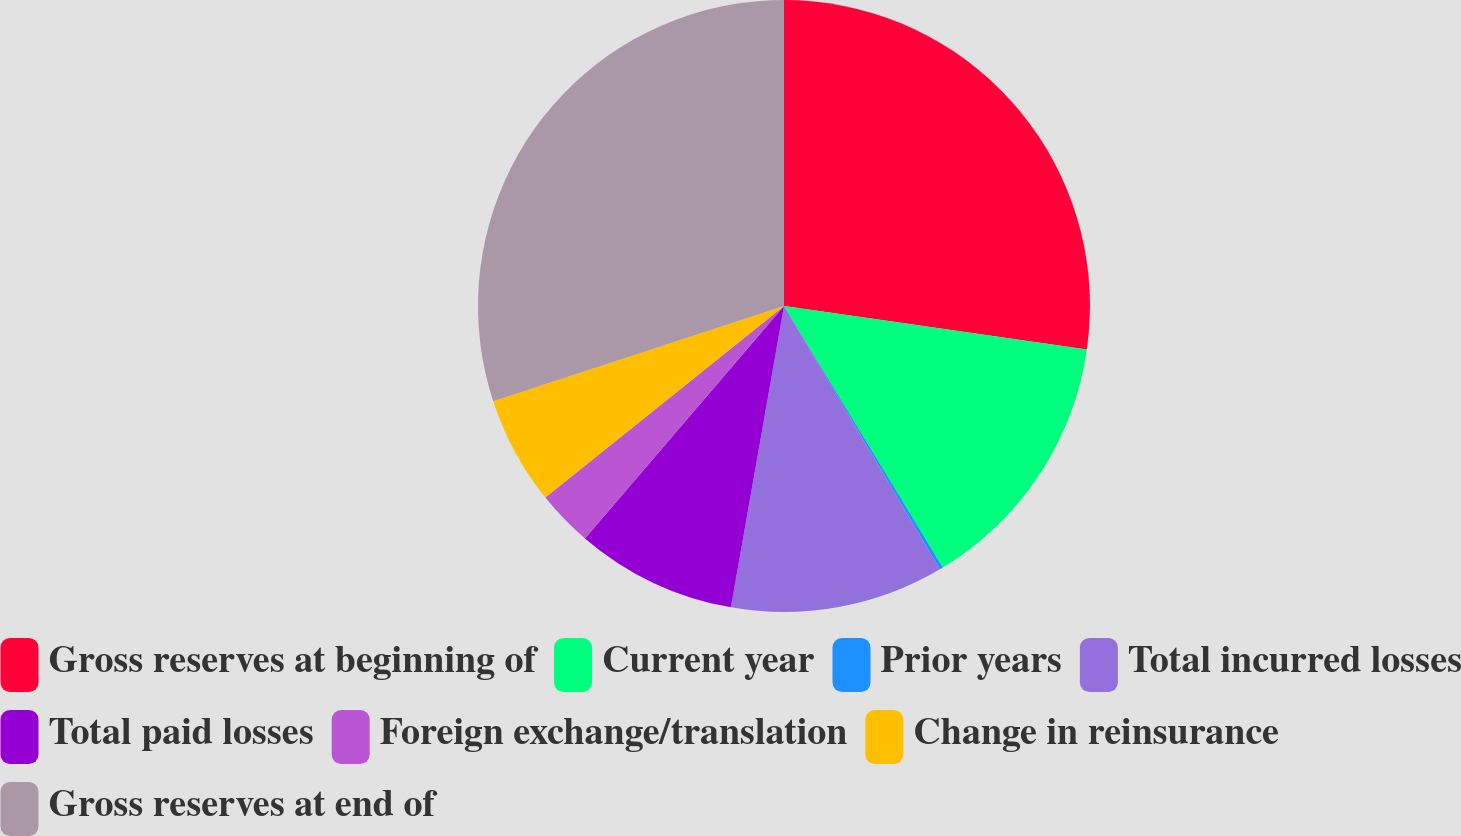Convert chart. <chart><loc_0><loc_0><loc_500><loc_500><pie_chart><fcel>Gross reserves at beginning of<fcel>Current year<fcel>Prior years<fcel>Total incurred losses<fcel>Total paid losses<fcel>Foreign exchange/translation<fcel>Change in reinsurance<fcel>Gross reserves at end of<nl><fcel>27.27%<fcel>14.05%<fcel>0.18%<fcel>11.28%<fcel>8.5%<fcel>2.96%<fcel>5.73%<fcel>30.04%<nl></chart> 